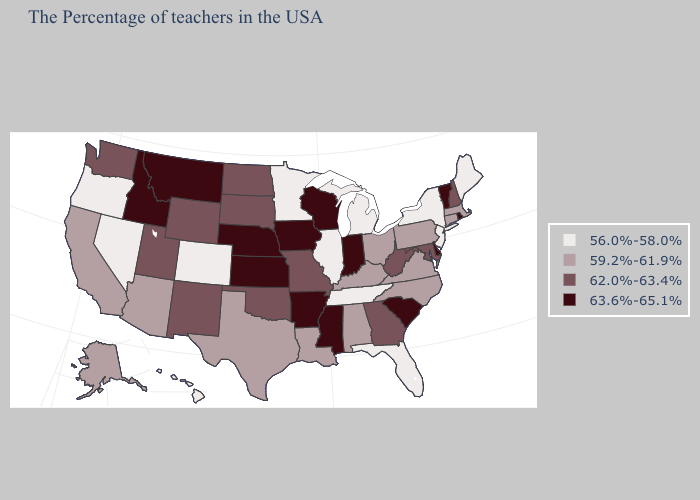What is the value of Rhode Island?
Write a very short answer. 63.6%-65.1%. Does the map have missing data?
Give a very brief answer. No. What is the highest value in the USA?
Answer briefly. 63.6%-65.1%. Name the states that have a value in the range 63.6%-65.1%?
Answer briefly. Rhode Island, Vermont, Delaware, South Carolina, Indiana, Wisconsin, Mississippi, Arkansas, Iowa, Kansas, Nebraska, Montana, Idaho. What is the value of Nebraska?
Give a very brief answer. 63.6%-65.1%. Is the legend a continuous bar?
Keep it brief. No. Name the states that have a value in the range 62.0%-63.4%?
Keep it brief. New Hampshire, Maryland, West Virginia, Georgia, Missouri, Oklahoma, South Dakota, North Dakota, Wyoming, New Mexico, Utah, Washington. Among the states that border Wyoming , which have the lowest value?
Answer briefly. Colorado. Does Mississippi have the highest value in the USA?
Give a very brief answer. Yes. What is the lowest value in the USA?
Give a very brief answer. 56.0%-58.0%. Among the states that border South Carolina , which have the highest value?
Concise answer only. Georgia. Among the states that border Georgia , does Tennessee have the lowest value?
Concise answer only. Yes. What is the highest value in states that border Illinois?
Be succinct. 63.6%-65.1%. Name the states that have a value in the range 62.0%-63.4%?
Short answer required. New Hampshire, Maryland, West Virginia, Georgia, Missouri, Oklahoma, South Dakota, North Dakota, Wyoming, New Mexico, Utah, Washington. What is the value of Wisconsin?
Keep it brief. 63.6%-65.1%. 